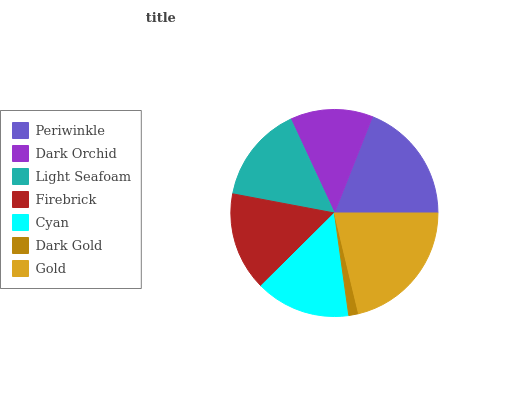Is Dark Gold the minimum?
Answer yes or no. Yes. Is Gold the maximum?
Answer yes or no. Yes. Is Dark Orchid the minimum?
Answer yes or no. No. Is Dark Orchid the maximum?
Answer yes or no. No. Is Periwinkle greater than Dark Orchid?
Answer yes or no. Yes. Is Dark Orchid less than Periwinkle?
Answer yes or no. Yes. Is Dark Orchid greater than Periwinkle?
Answer yes or no. No. Is Periwinkle less than Dark Orchid?
Answer yes or no. No. Is Light Seafoam the high median?
Answer yes or no. Yes. Is Light Seafoam the low median?
Answer yes or no. Yes. Is Gold the high median?
Answer yes or no. No. Is Dark Gold the low median?
Answer yes or no. No. 